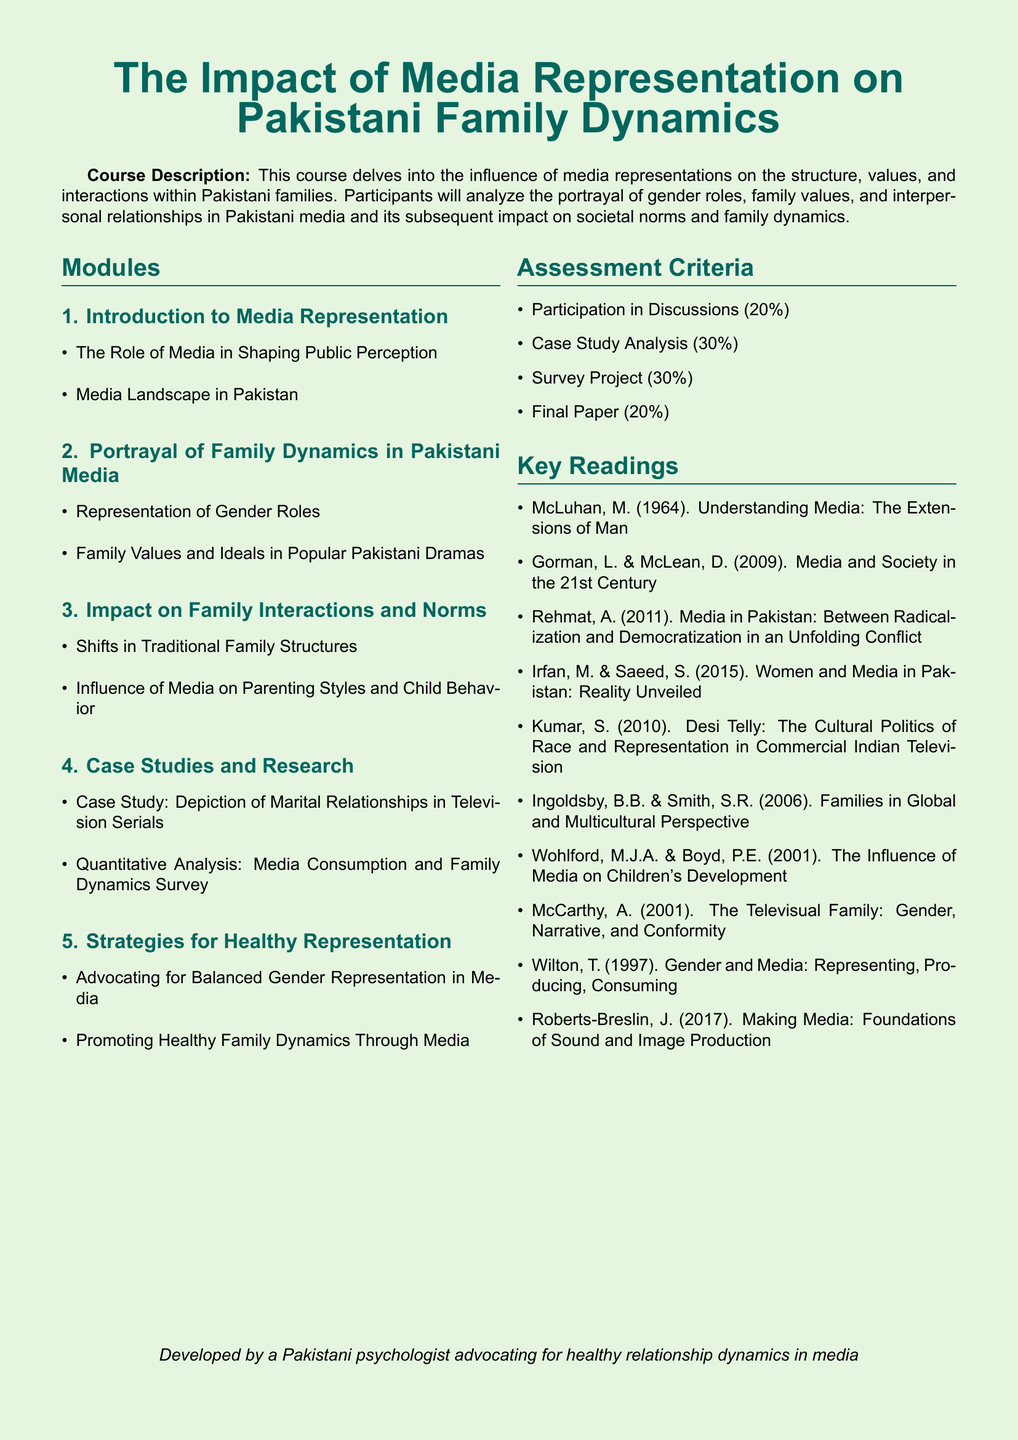What is the title of the syllabus? The title located at the top of the document states the course name, which is "The Impact of Media Representation on Pakistani Family Dynamics."
Answer: The Impact of Media Representation on Pakistani Family Dynamics How many modules are listed in the syllabus? The syllabus contains a section that enumerates the modules, revealing a total of five.
Answer: 5 What percentage of the assessment criteria is dedicated to participation in discussions? The document outlines the assessment criteria, where participation in discussions accounts for twenty percent.
Answer: 20% What is a key focus in the second module? The second module specifies the representation of gender roles, indicating a focus on how gender is portrayed in the media.
Answer: Representation of Gender Roles Which reading discusses media's influence on children's development? A key reading in the syllabus specifically addresses the subject of children's development in relation to media.
Answer: Wohlford, M.J.A. & Boyd, P.E. (2001). The Influence of Media on Children's Development What is the final paper's weight in the assessment criteria? The assessment criteria detail the weight of various components, stating the final paper makes up twenty percent of the total assessment.
Answer: 20% 